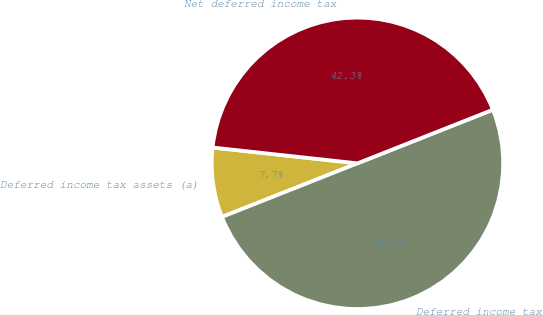Convert chart to OTSL. <chart><loc_0><loc_0><loc_500><loc_500><pie_chart><fcel>Deferred income tax assets (a)<fcel>Deferred income tax<fcel>Net deferred income tax<nl><fcel>7.73%<fcel>50.0%<fcel>42.27%<nl></chart> 